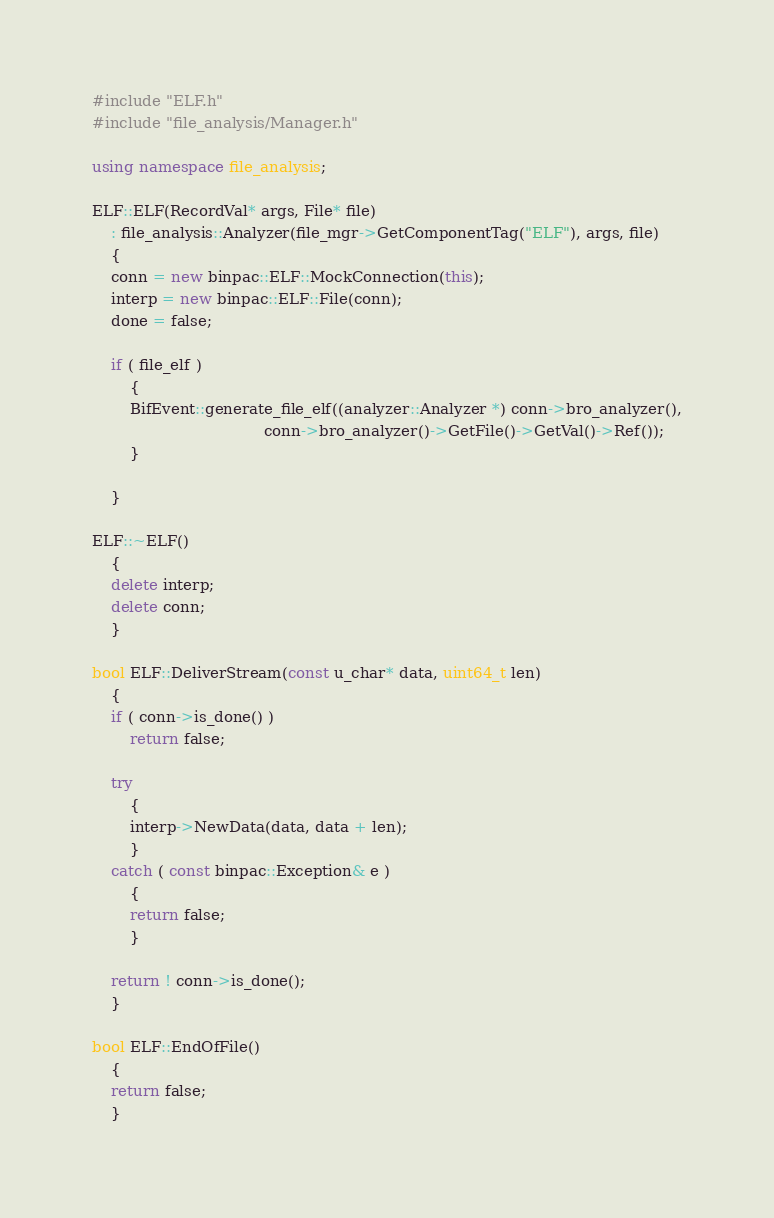Convert code to text. <code><loc_0><loc_0><loc_500><loc_500><_C++_>#include "ELF.h"
#include "file_analysis/Manager.h"

using namespace file_analysis;

ELF::ELF(RecordVal* args, File* file)
    : file_analysis::Analyzer(file_mgr->GetComponentTag("ELF"), args, file)
	{
	conn = new binpac::ELF::MockConnection(this);
	interp = new binpac::ELF::File(conn);
	done = false;

    if ( file_elf )
        {
        BifEvent::generate_file_elf((analyzer::Analyzer *) conn->bro_analyzer(),
                                    conn->bro_analyzer()->GetFile()->GetVal()->Ref());
        }

    }

ELF::~ELF()
	{
	delete interp;
	delete conn;
	}

bool ELF::DeliverStream(const u_char* data, uint64_t len)
	{
	if ( conn->is_done() )
		return false;

	try
		{
		interp->NewData(data, data + len);
		}
	catch ( const binpac::Exception& e )
		{
		return false;
		}

	return ! conn->is_done();
	}

bool ELF::EndOfFile()
	{
	return false;
	}
</code> 